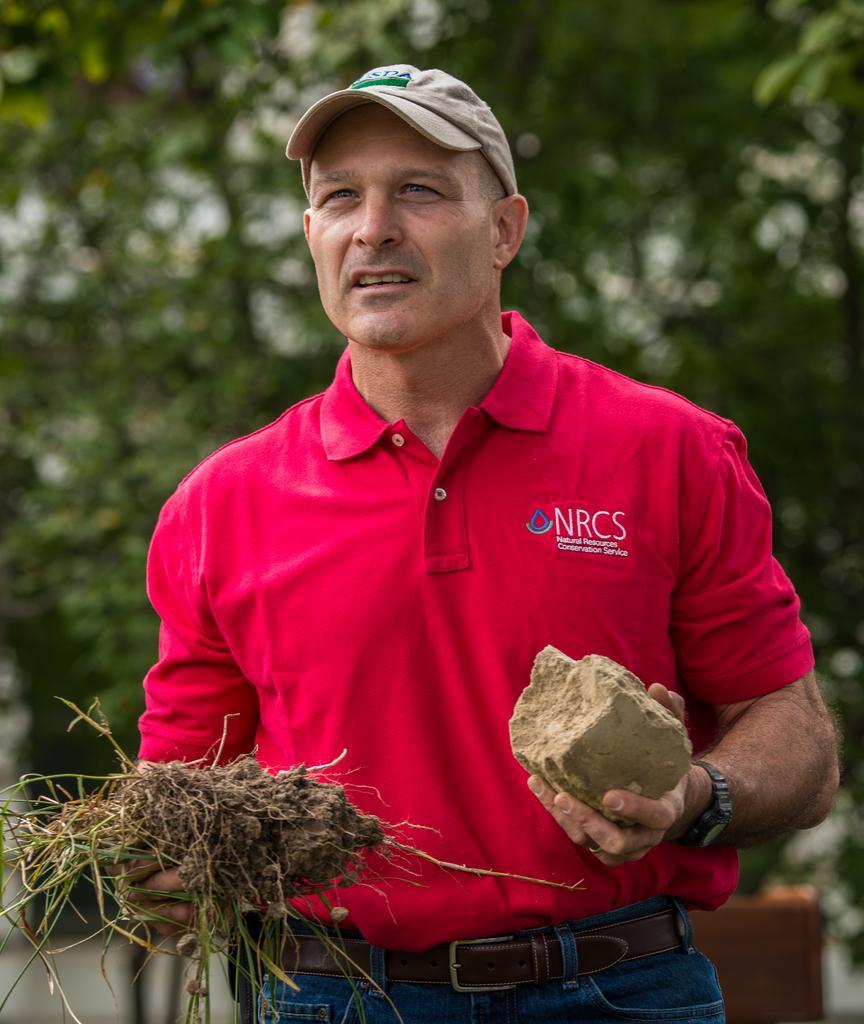Describe this image in one or two sentences. In this image there is a person holding stone and grass. There are trees in the background. 